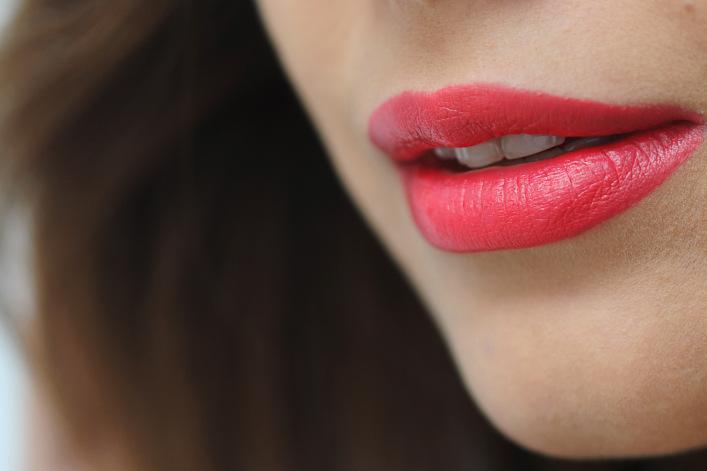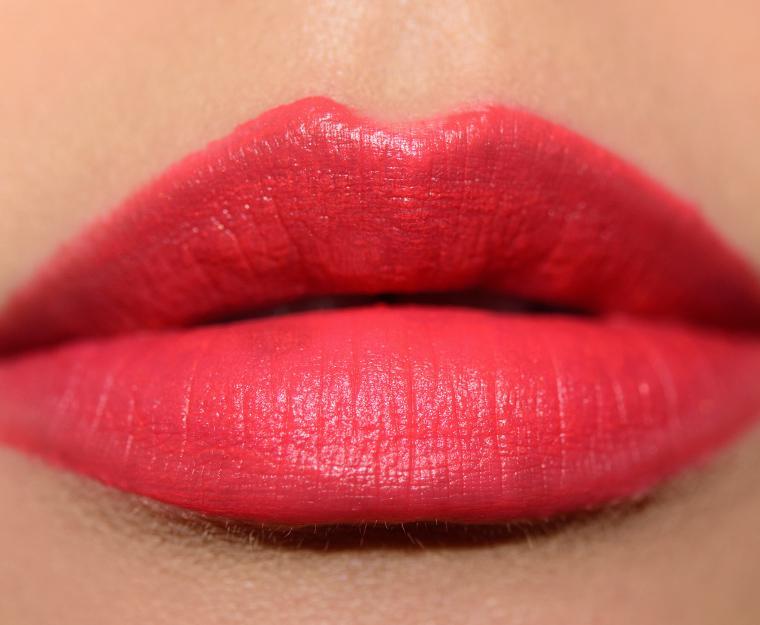The first image is the image on the left, the second image is the image on the right. Considering the images on both sides, is "A woman's teeth are visible in one of the images." valid? Answer yes or no. Yes. The first image is the image on the left, the second image is the image on the right. Analyze the images presented: Is the assertion "Tinted lips and smears of different lipstick colors are shown, along with containers of lip makeup." valid? Answer yes or no. No. 